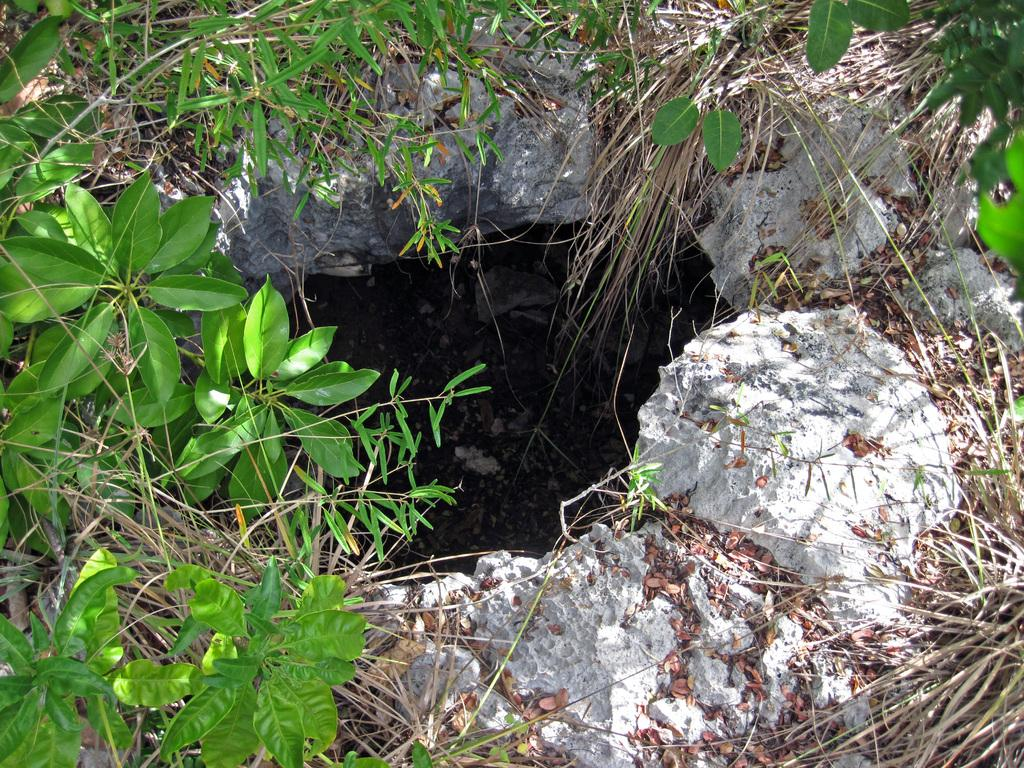What type of vegetation can be seen in the image? There are plants in the image. What is the condition of the grass in the image? Dry grass is present in the image. What type of material is visible in the image? Stones are visible in the image. What feature can be seen in the ground in the image? There is a pit in the image. What type of crown is worn by the steam in the image? There is no crown or steam present in the image. What is the tendency of the plants in the image? The provided facts do not mention any specific tendency of the plants in the image. 